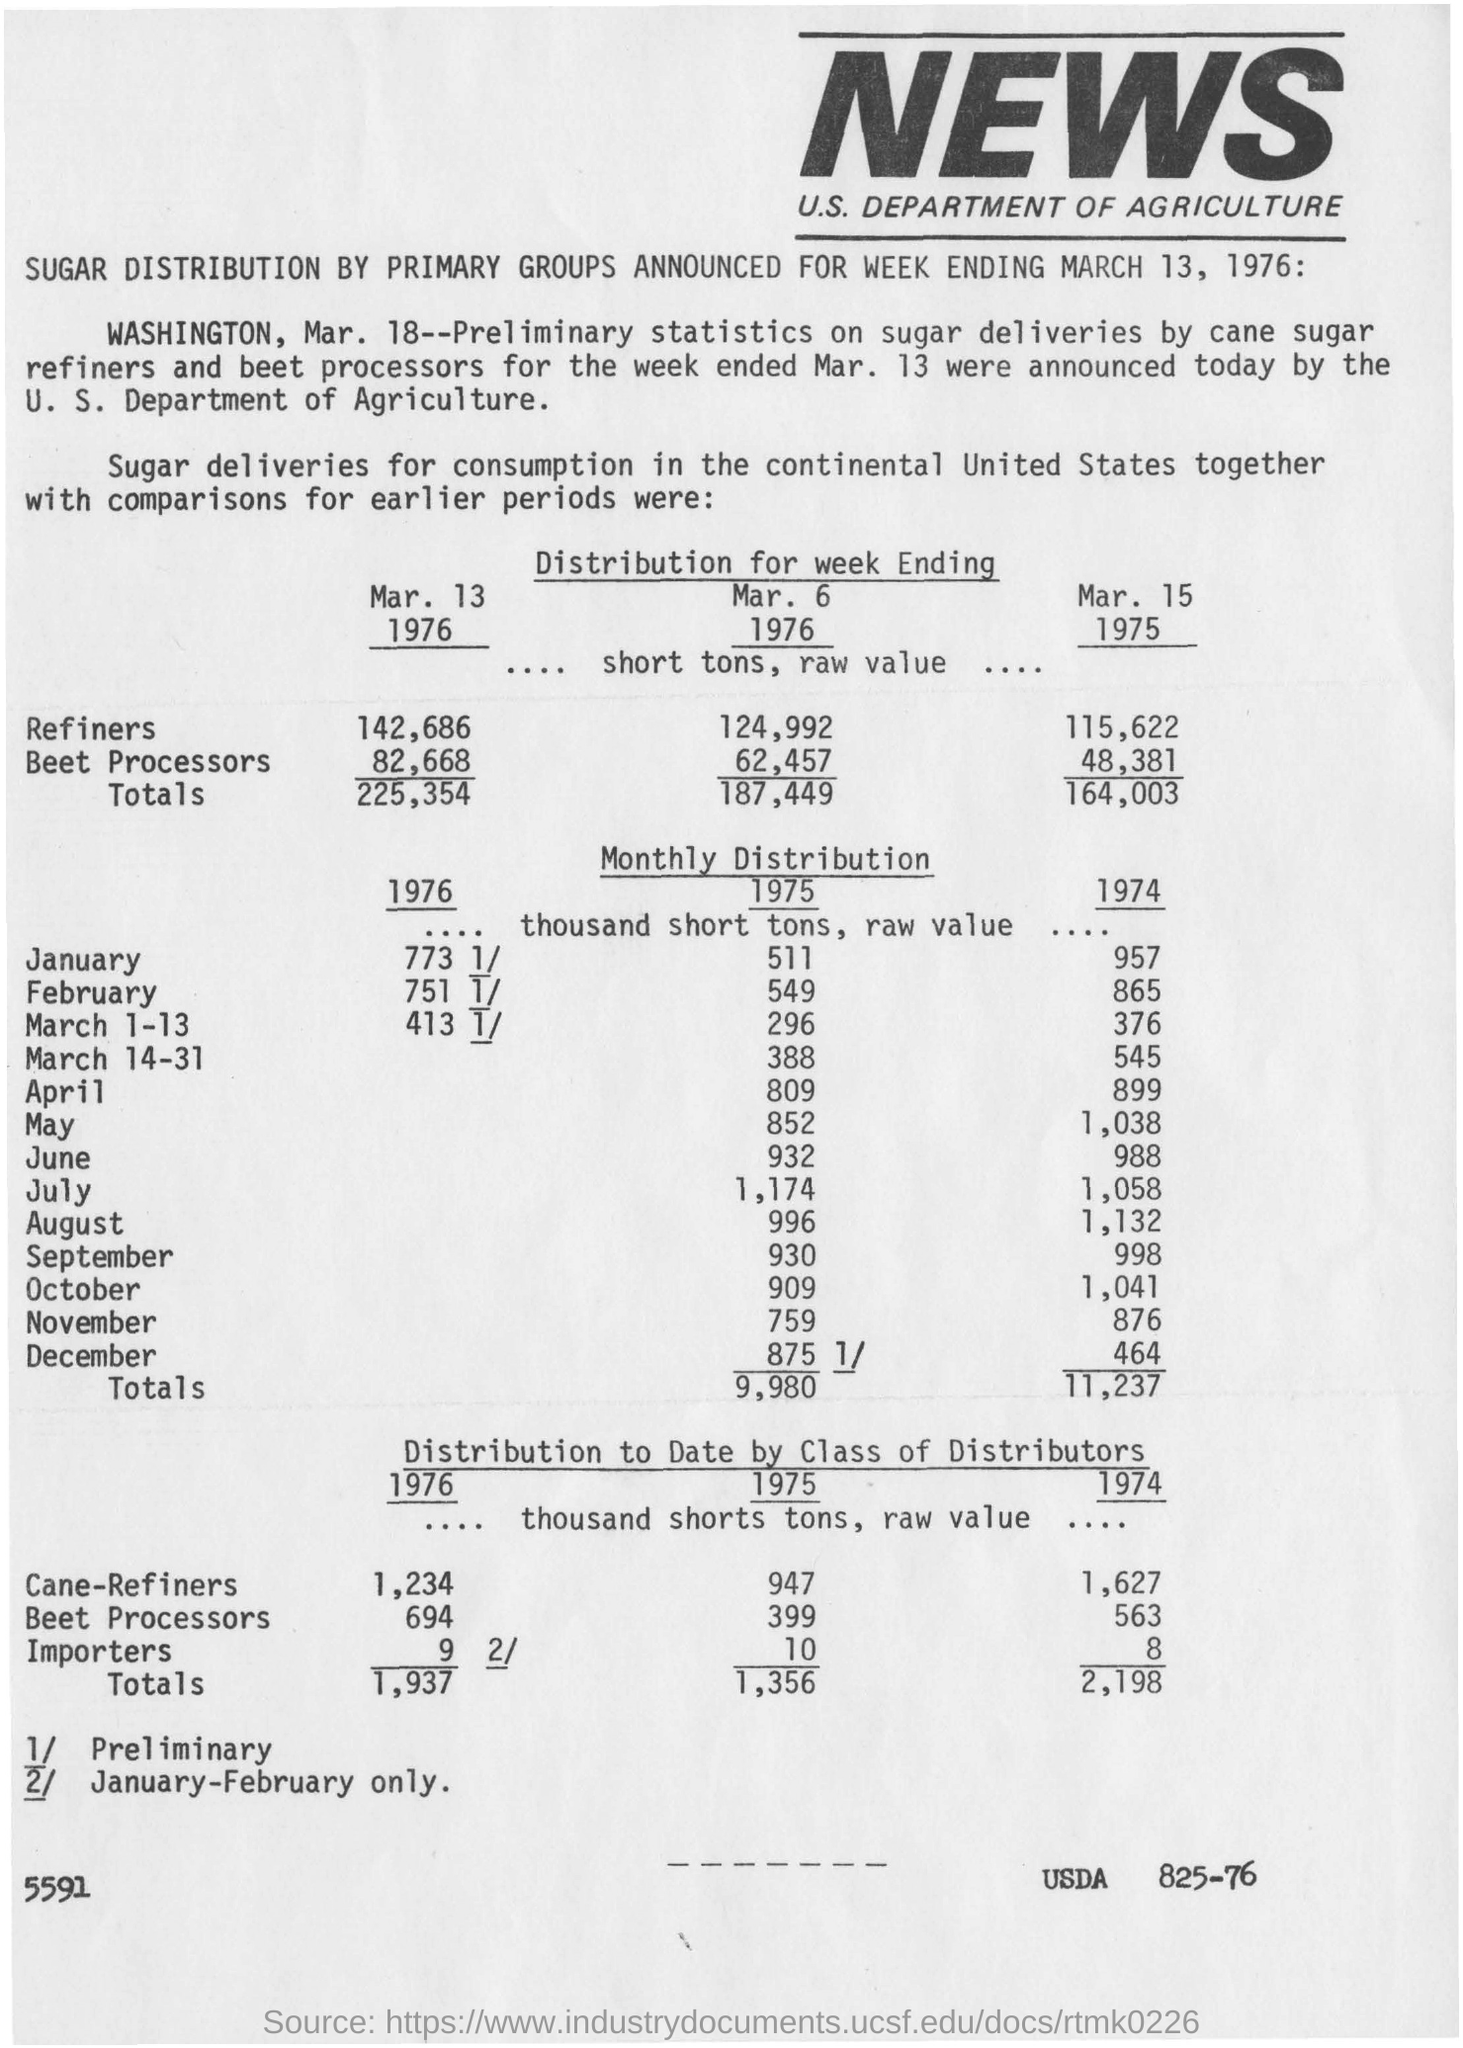The article mentions the distribution of which product?
Your answer should be very brief. Sugar. News coverage is for which country?
Your answer should be very brief. U.S. What is the value of importers for the year 1975?
Make the answer very short. 10. 